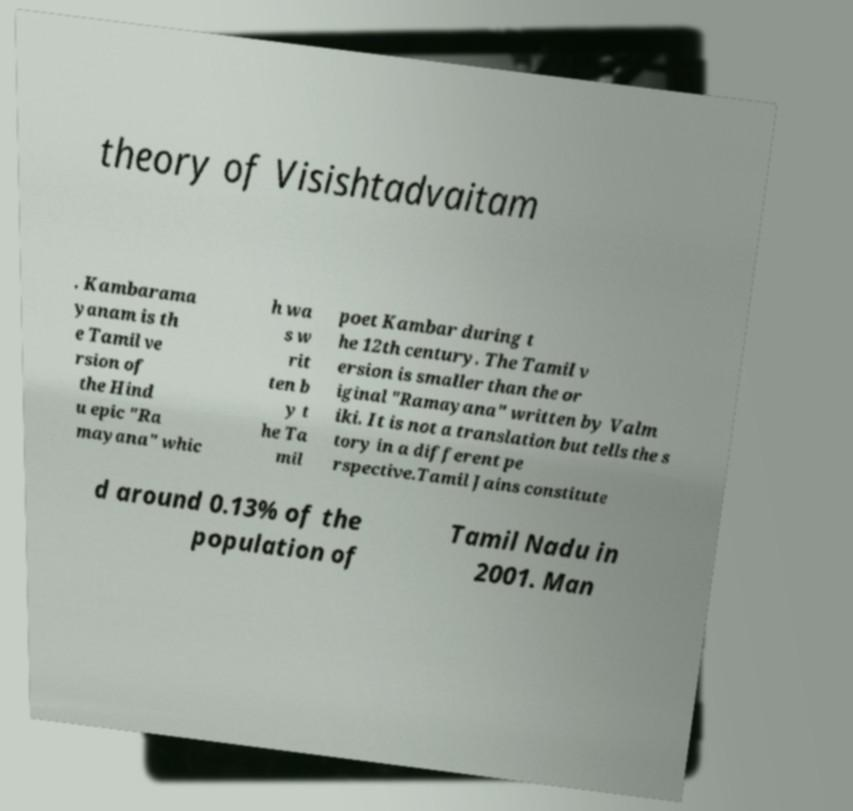Please read and relay the text visible in this image. What does it say? theory of Visishtadvaitam . Kambarama yanam is th e Tamil ve rsion of the Hind u epic "Ra mayana" whic h wa s w rit ten b y t he Ta mil poet Kambar during t he 12th century. The Tamil v ersion is smaller than the or iginal "Ramayana" written by Valm iki. It is not a translation but tells the s tory in a different pe rspective.Tamil Jains constitute d around 0.13% of the population of Tamil Nadu in 2001. Man 